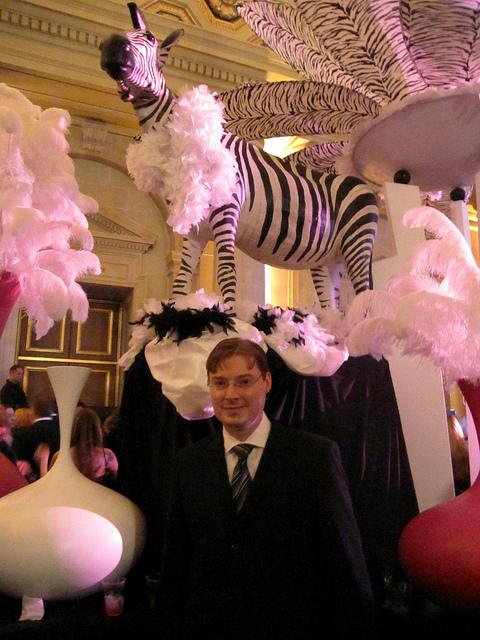Does this man have normal vision?
Give a very brief answer. No. What does the zebra have around it's neck?
Be succinct. Feathers. What color is the man's shirt?
Write a very short answer. White. 